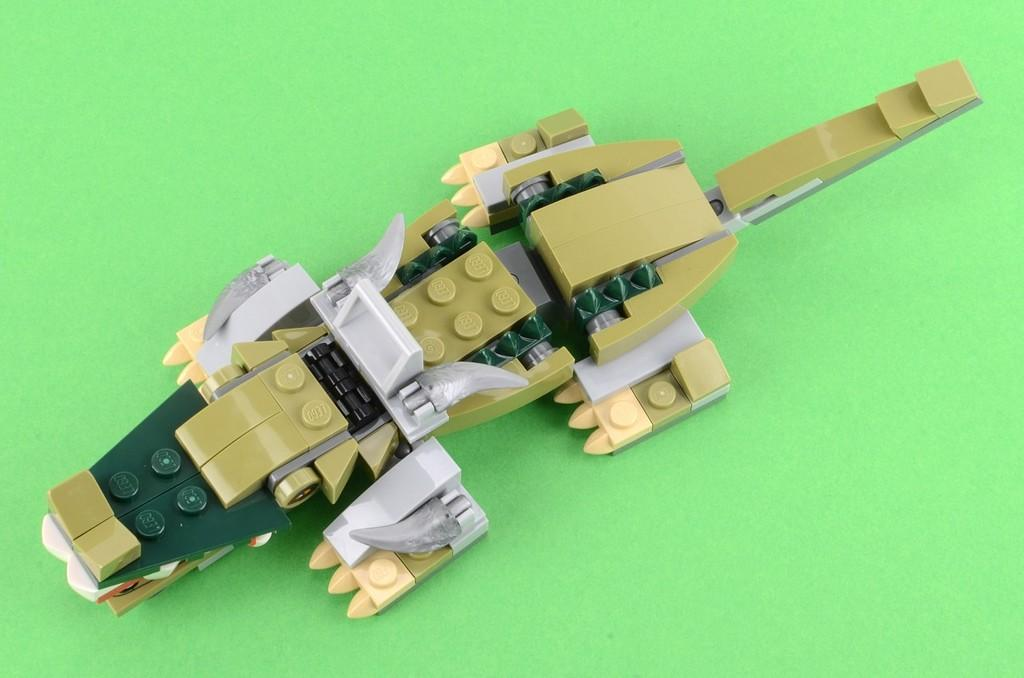What is the main subject of the image? The main subject of the image is a jigsaw puzzle. What colors are present on the jigsaw puzzle? The jigsaw puzzle has green and grey colors. What is the jigsaw puzzle placed on in the image? The jigsaw puzzle is placed on a green cloth. What type of lettuce is visible in the image? There is no lettuce present in the image. What trick is being performed with the jigsaw puzzle in the image? There is no trick being performed with the jigsaw puzzle in the image; it is simply placed on a green cloth. Can you see a duck in the image? There is no duck present in the image. 